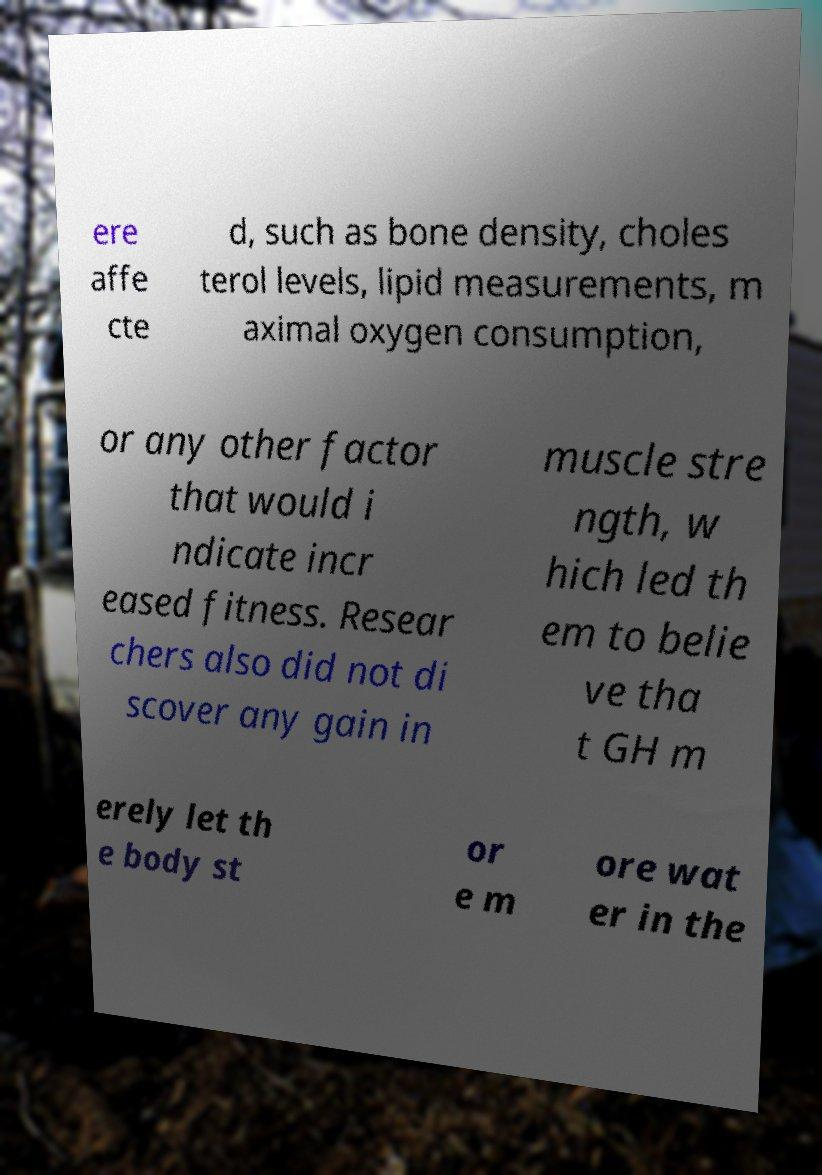Can you read and provide the text displayed in the image?This photo seems to have some interesting text. Can you extract and type it out for me? ere affe cte d, such as bone density, choles terol levels, lipid measurements, m aximal oxygen consumption, or any other factor that would i ndicate incr eased fitness. Resear chers also did not di scover any gain in muscle stre ngth, w hich led th em to belie ve tha t GH m erely let th e body st or e m ore wat er in the 